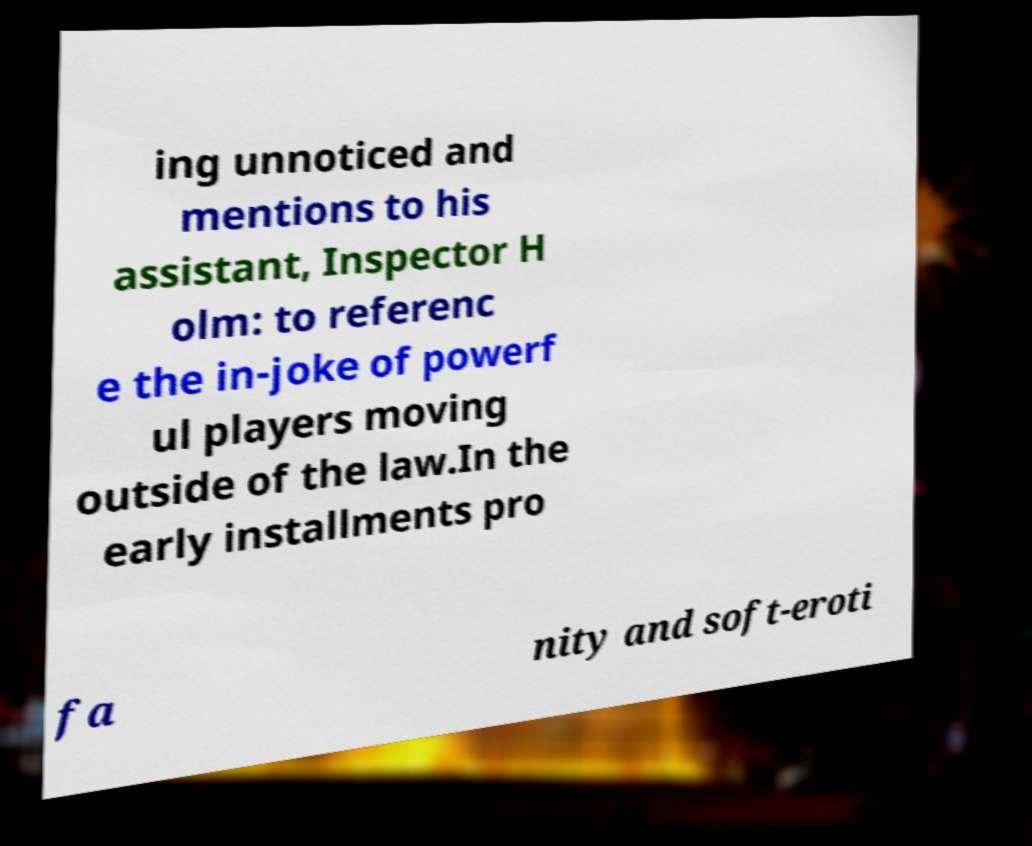Could you extract and type out the text from this image? ing unnoticed and mentions to his assistant, Inspector H olm: to referenc e the in-joke of powerf ul players moving outside of the law.In the early installments pro fa nity and soft-eroti 